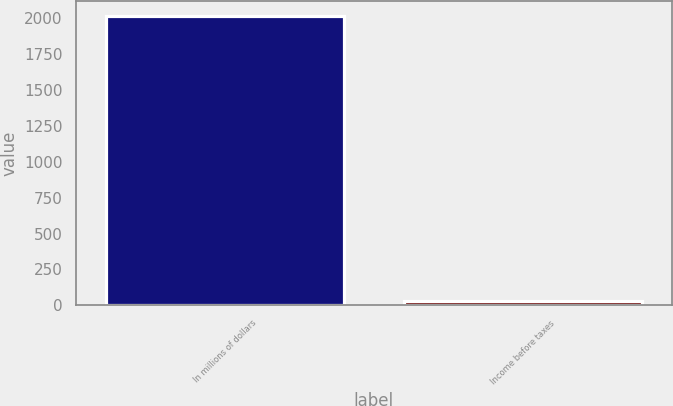Convert chart to OTSL. <chart><loc_0><loc_0><loc_500><loc_500><bar_chart><fcel>In millions of dollars<fcel>Income before taxes<nl><fcel>2017<fcel>31<nl></chart> 